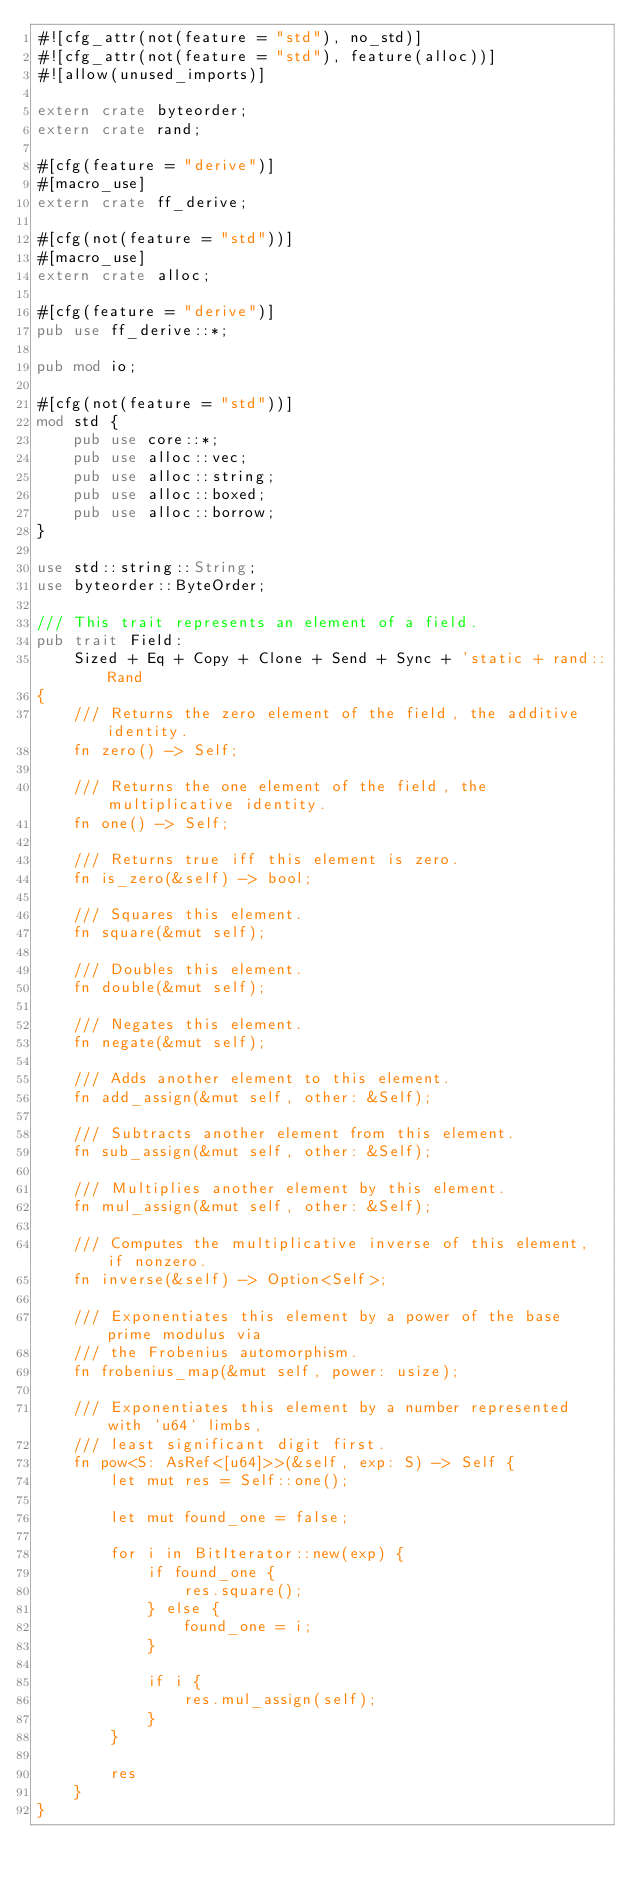<code> <loc_0><loc_0><loc_500><loc_500><_Rust_>#![cfg_attr(not(feature = "std"), no_std)]
#![cfg_attr(not(feature = "std"), feature(alloc))]
#![allow(unused_imports)]

extern crate byteorder;
extern crate rand;

#[cfg(feature = "derive")]
#[macro_use]
extern crate ff_derive;

#[cfg(not(feature = "std"))]
#[macro_use]
extern crate alloc;

#[cfg(feature = "derive")]
pub use ff_derive::*;

pub mod io;

#[cfg(not(feature = "std"))]
mod std {
	pub use core::*;
	pub use alloc::vec;
	pub use alloc::string;
	pub use alloc::boxed;
	pub use alloc::borrow;
}

use std::string::String;
use byteorder::ByteOrder;

/// This trait represents an element of a field.
pub trait Field:
    Sized + Eq + Copy + Clone + Send + Sync + 'static + rand::Rand
{
    /// Returns the zero element of the field, the additive identity.
    fn zero() -> Self;

    /// Returns the one element of the field, the multiplicative identity.
    fn one() -> Self;

    /// Returns true iff this element is zero.
    fn is_zero(&self) -> bool;

    /// Squares this element.
    fn square(&mut self);

    /// Doubles this element.
    fn double(&mut self);

    /// Negates this element.
    fn negate(&mut self);

    /// Adds another element to this element.
    fn add_assign(&mut self, other: &Self);

    /// Subtracts another element from this element.
    fn sub_assign(&mut self, other: &Self);

    /// Multiplies another element by this element.
    fn mul_assign(&mut self, other: &Self);

    /// Computes the multiplicative inverse of this element, if nonzero.
    fn inverse(&self) -> Option<Self>;

    /// Exponentiates this element by a power of the base prime modulus via
    /// the Frobenius automorphism.
    fn frobenius_map(&mut self, power: usize);

    /// Exponentiates this element by a number represented with `u64` limbs,
    /// least significant digit first.
    fn pow<S: AsRef<[u64]>>(&self, exp: S) -> Self {
        let mut res = Self::one();

        let mut found_one = false;

        for i in BitIterator::new(exp) {
            if found_one {
                res.square();
            } else {
                found_one = i;
            }

            if i {
                res.mul_assign(self);
            }
        }

        res
    }
}
</code> 